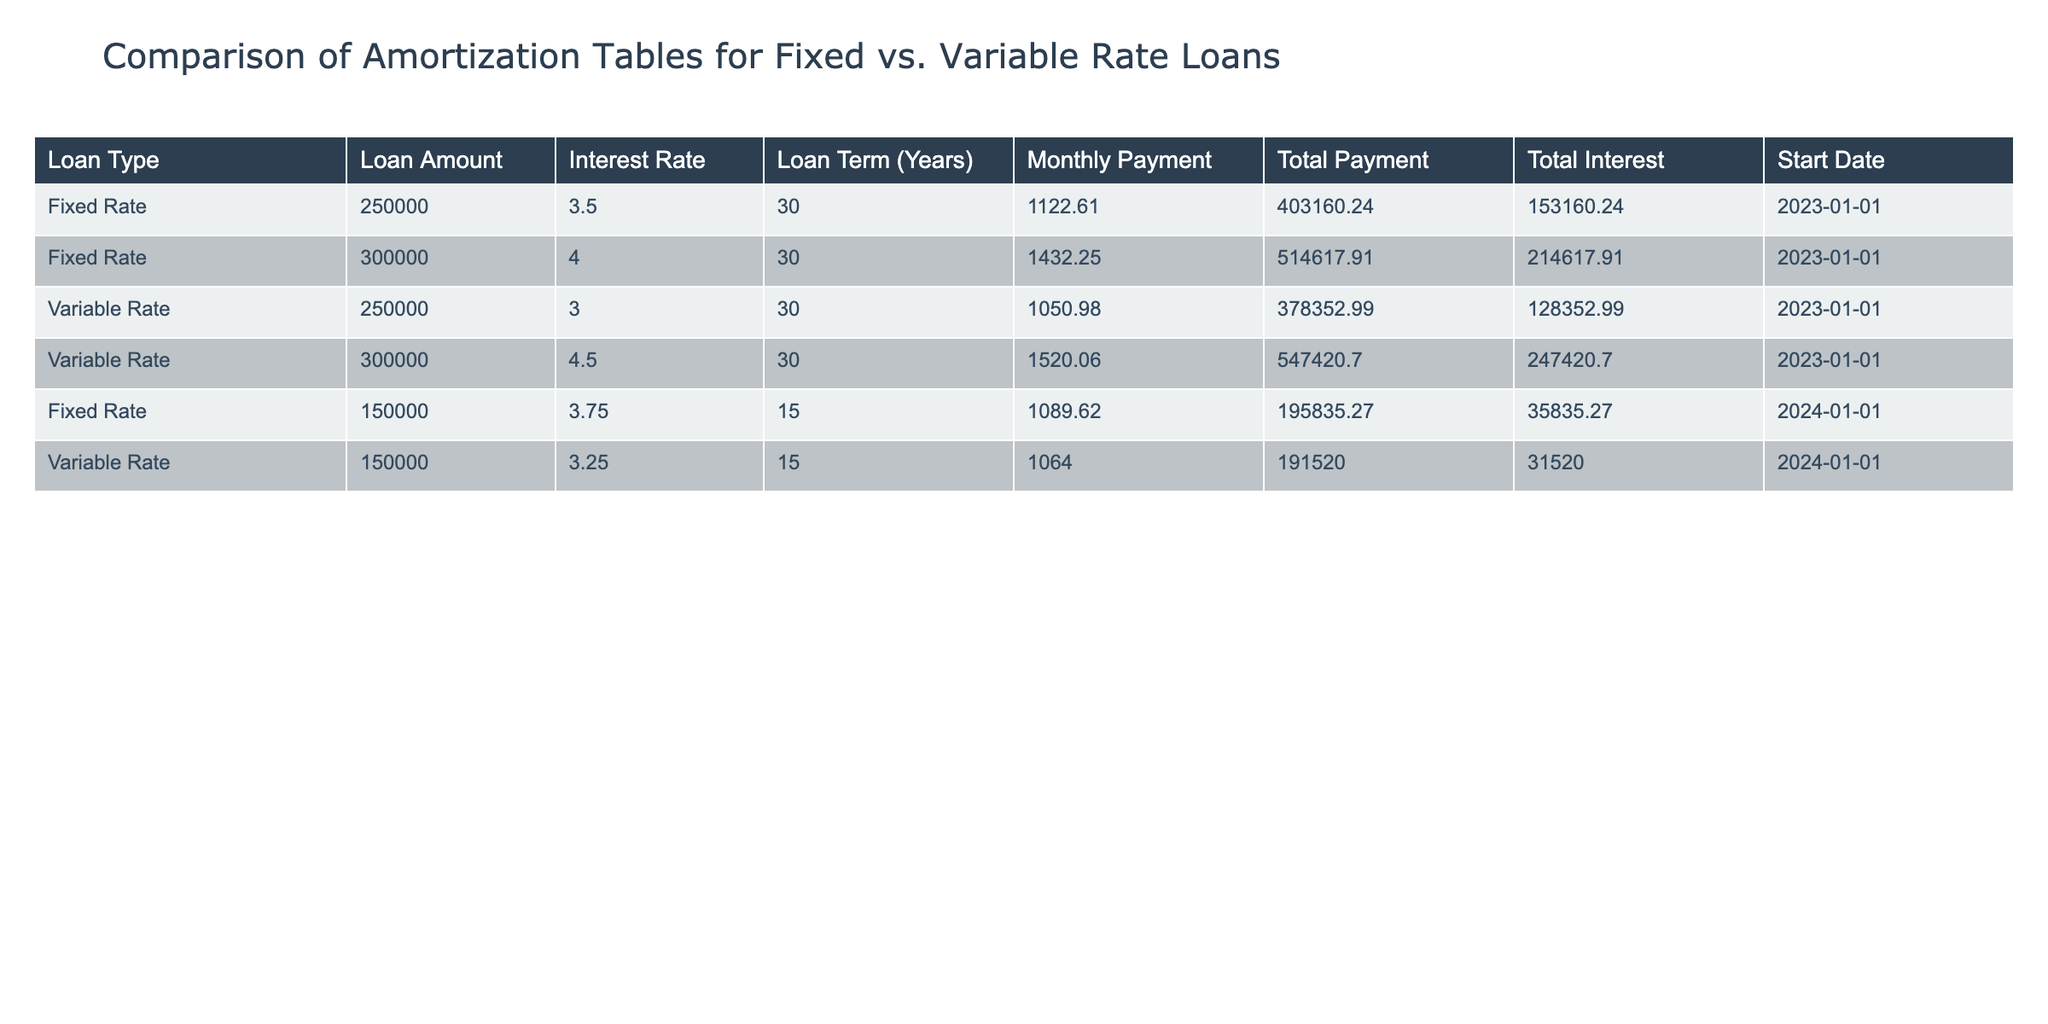What is the total payment for the Fixed Rate loan of 250,000? According to the table, the total payment for the Fixed Rate loan of 250,000 is listed as 403,160.24.
Answer: 403,160.24 Which loan type has the highest total interest? By examining the total interest column for both loan types, we find that the Variable Rate loan of 300,000 has a total interest of 247,420.70, which is greater than all other loans listed.
Answer: Variable Rate What is the difference in monthly payments between the Fixed Rate loan of 300,000 and the Variable Rate loan of 300,000? The monthly payment for the Fixed Rate loan of 300,000 is 1,432.25, while the Variable Rate loan of 300,000 has a monthly payment of 1,520.06. The difference is calculated as 1,520.06 - 1,432.25 = 87.81.
Answer: 87.81 Is the total interest for the Fixed Rate loan of 150,000 greater than that of its Variable Rate counterpart? The total interest for the Fixed Rate loan of 150,000 is 35,835.27, while for the Variable Rate loan of 150,000 it is 31,520.00. Since 35,835.27 is greater than 31,520.00, the statement is true.
Answer: Yes What is the average monthly payment for all loans listed? To find the average monthly payment, we sum all monthly payments: (1,122.61 + 1,432.25 + 1,050.98 + 1,520.06 + 1,089.62 + 1,064.00) = 6,779.52. There are 6 loans, so the average is 6,779.52 / 6 = 1,129.92.
Answer: 1,129.92 